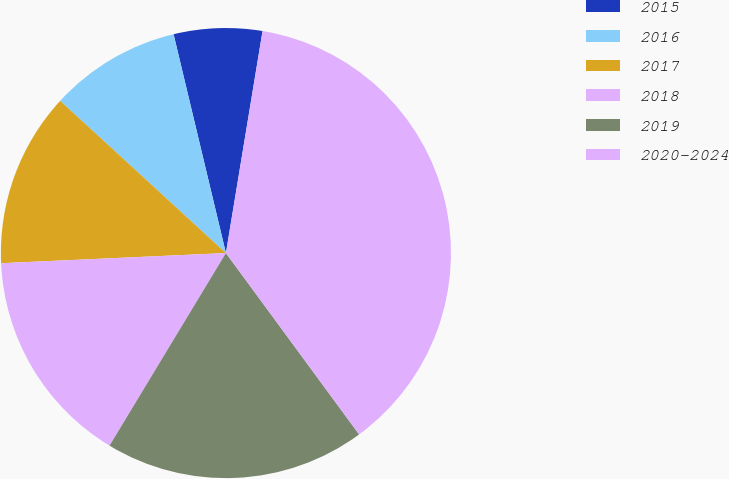Convert chart. <chart><loc_0><loc_0><loc_500><loc_500><pie_chart><fcel>2015<fcel>2016<fcel>2017<fcel>2018<fcel>2019<fcel>2020-2024<nl><fcel>6.34%<fcel>9.44%<fcel>12.54%<fcel>15.63%<fcel>18.73%<fcel>37.31%<nl></chart> 